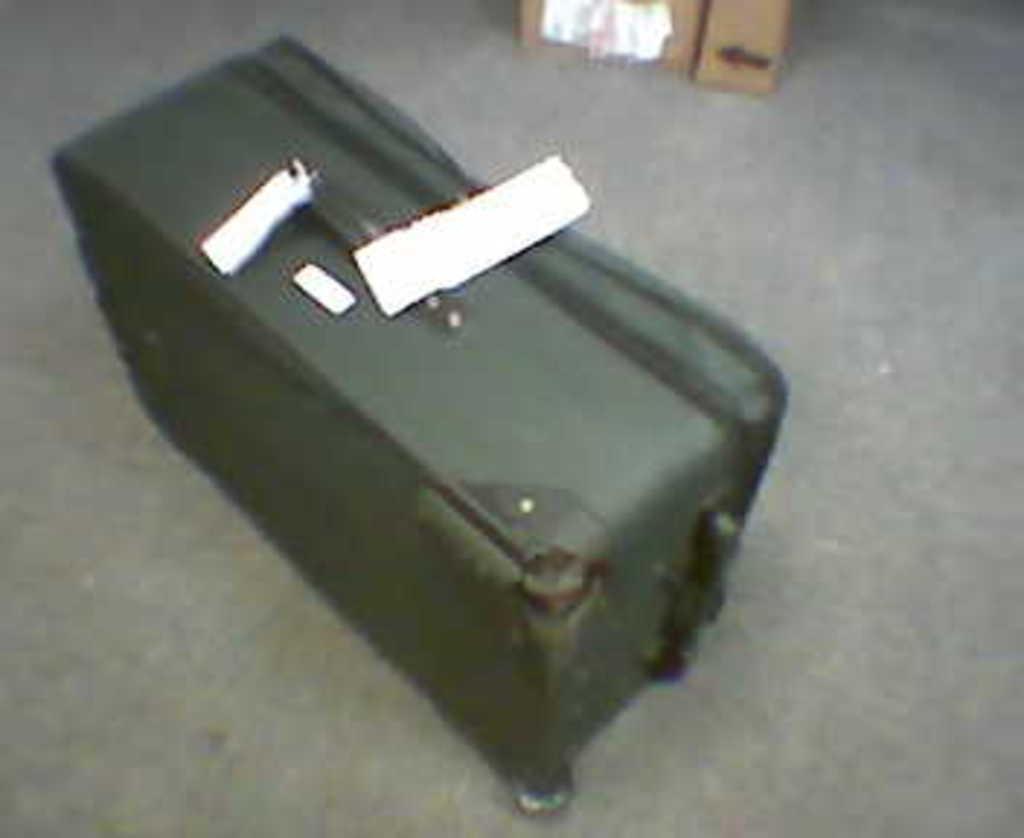Describe this image in one or two sentences. There is a green traveler bag with a tag on it on the floor and there is a cardboard box at the back. 